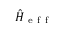Convert formula to latex. <formula><loc_0><loc_0><loc_500><loc_500>\hat { H } _ { e f f }</formula> 